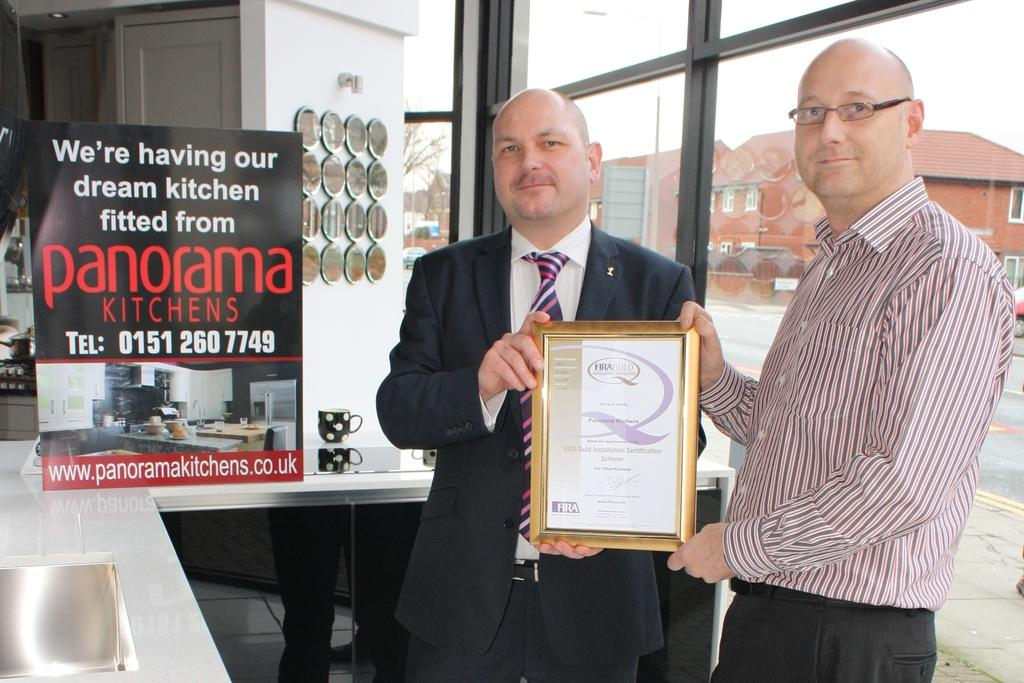<image>
Summarize the visual content of the image. Two men standing next to a sign from panorama kitchens. 